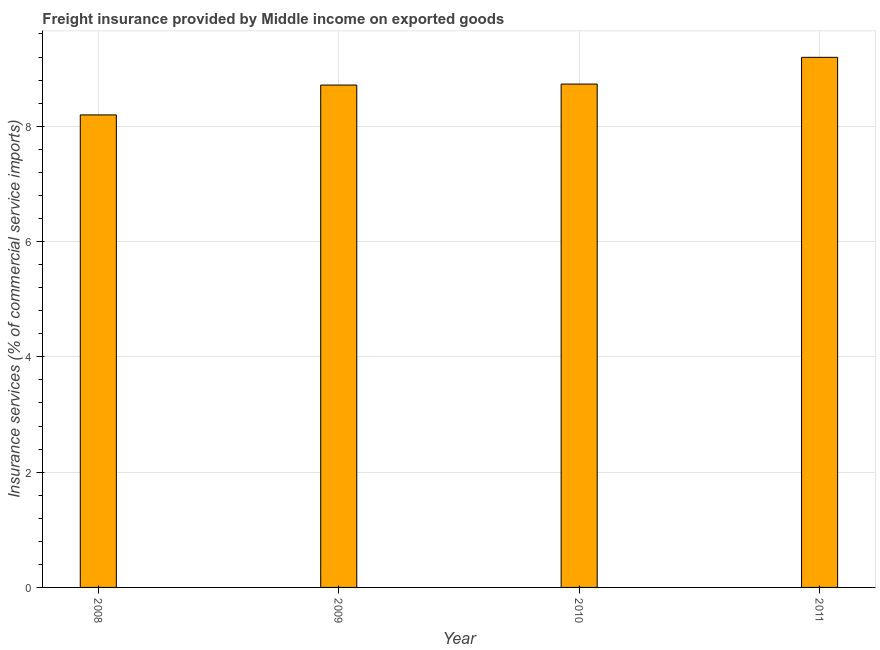Does the graph contain any zero values?
Your answer should be very brief. No. Does the graph contain grids?
Provide a succinct answer. Yes. What is the title of the graph?
Your answer should be very brief. Freight insurance provided by Middle income on exported goods . What is the label or title of the Y-axis?
Provide a succinct answer. Insurance services (% of commercial service imports). What is the freight insurance in 2011?
Provide a short and direct response. 9.2. Across all years, what is the maximum freight insurance?
Ensure brevity in your answer.  9.2. Across all years, what is the minimum freight insurance?
Your answer should be very brief. 8.2. In which year was the freight insurance maximum?
Offer a very short reply. 2011. In which year was the freight insurance minimum?
Your answer should be very brief. 2008. What is the sum of the freight insurance?
Offer a very short reply. 34.84. What is the difference between the freight insurance in 2009 and 2011?
Make the answer very short. -0.48. What is the average freight insurance per year?
Your answer should be very brief. 8.71. What is the median freight insurance?
Provide a short and direct response. 8.72. Do a majority of the years between 2011 and 2010 (inclusive) have freight insurance greater than 2.4 %?
Your answer should be compact. No. What is the ratio of the freight insurance in 2008 to that in 2010?
Provide a short and direct response. 0.94. Is the freight insurance in 2008 less than that in 2009?
Your answer should be very brief. Yes. Is the difference between the freight insurance in 2008 and 2011 greater than the difference between any two years?
Provide a succinct answer. Yes. What is the difference between the highest and the second highest freight insurance?
Your answer should be compact. 0.46. How many bars are there?
Offer a very short reply. 4. Are all the bars in the graph horizontal?
Give a very brief answer. No. How many years are there in the graph?
Give a very brief answer. 4. What is the difference between two consecutive major ticks on the Y-axis?
Keep it short and to the point. 2. Are the values on the major ticks of Y-axis written in scientific E-notation?
Make the answer very short. No. What is the Insurance services (% of commercial service imports) of 2008?
Provide a succinct answer. 8.2. What is the Insurance services (% of commercial service imports) in 2009?
Your response must be concise. 8.71. What is the Insurance services (% of commercial service imports) in 2010?
Keep it short and to the point. 8.73. What is the Insurance services (% of commercial service imports) in 2011?
Offer a terse response. 9.2. What is the difference between the Insurance services (% of commercial service imports) in 2008 and 2009?
Keep it short and to the point. -0.52. What is the difference between the Insurance services (% of commercial service imports) in 2008 and 2010?
Keep it short and to the point. -0.54. What is the difference between the Insurance services (% of commercial service imports) in 2008 and 2011?
Ensure brevity in your answer.  -1. What is the difference between the Insurance services (% of commercial service imports) in 2009 and 2010?
Provide a short and direct response. -0.02. What is the difference between the Insurance services (% of commercial service imports) in 2009 and 2011?
Give a very brief answer. -0.48. What is the difference between the Insurance services (% of commercial service imports) in 2010 and 2011?
Give a very brief answer. -0.46. What is the ratio of the Insurance services (% of commercial service imports) in 2008 to that in 2009?
Offer a terse response. 0.94. What is the ratio of the Insurance services (% of commercial service imports) in 2008 to that in 2010?
Keep it short and to the point. 0.94. What is the ratio of the Insurance services (% of commercial service imports) in 2008 to that in 2011?
Your answer should be very brief. 0.89. What is the ratio of the Insurance services (% of commercial service imports) in 2009 to that in 2011?
Keep it short and to the point. 0.95. 